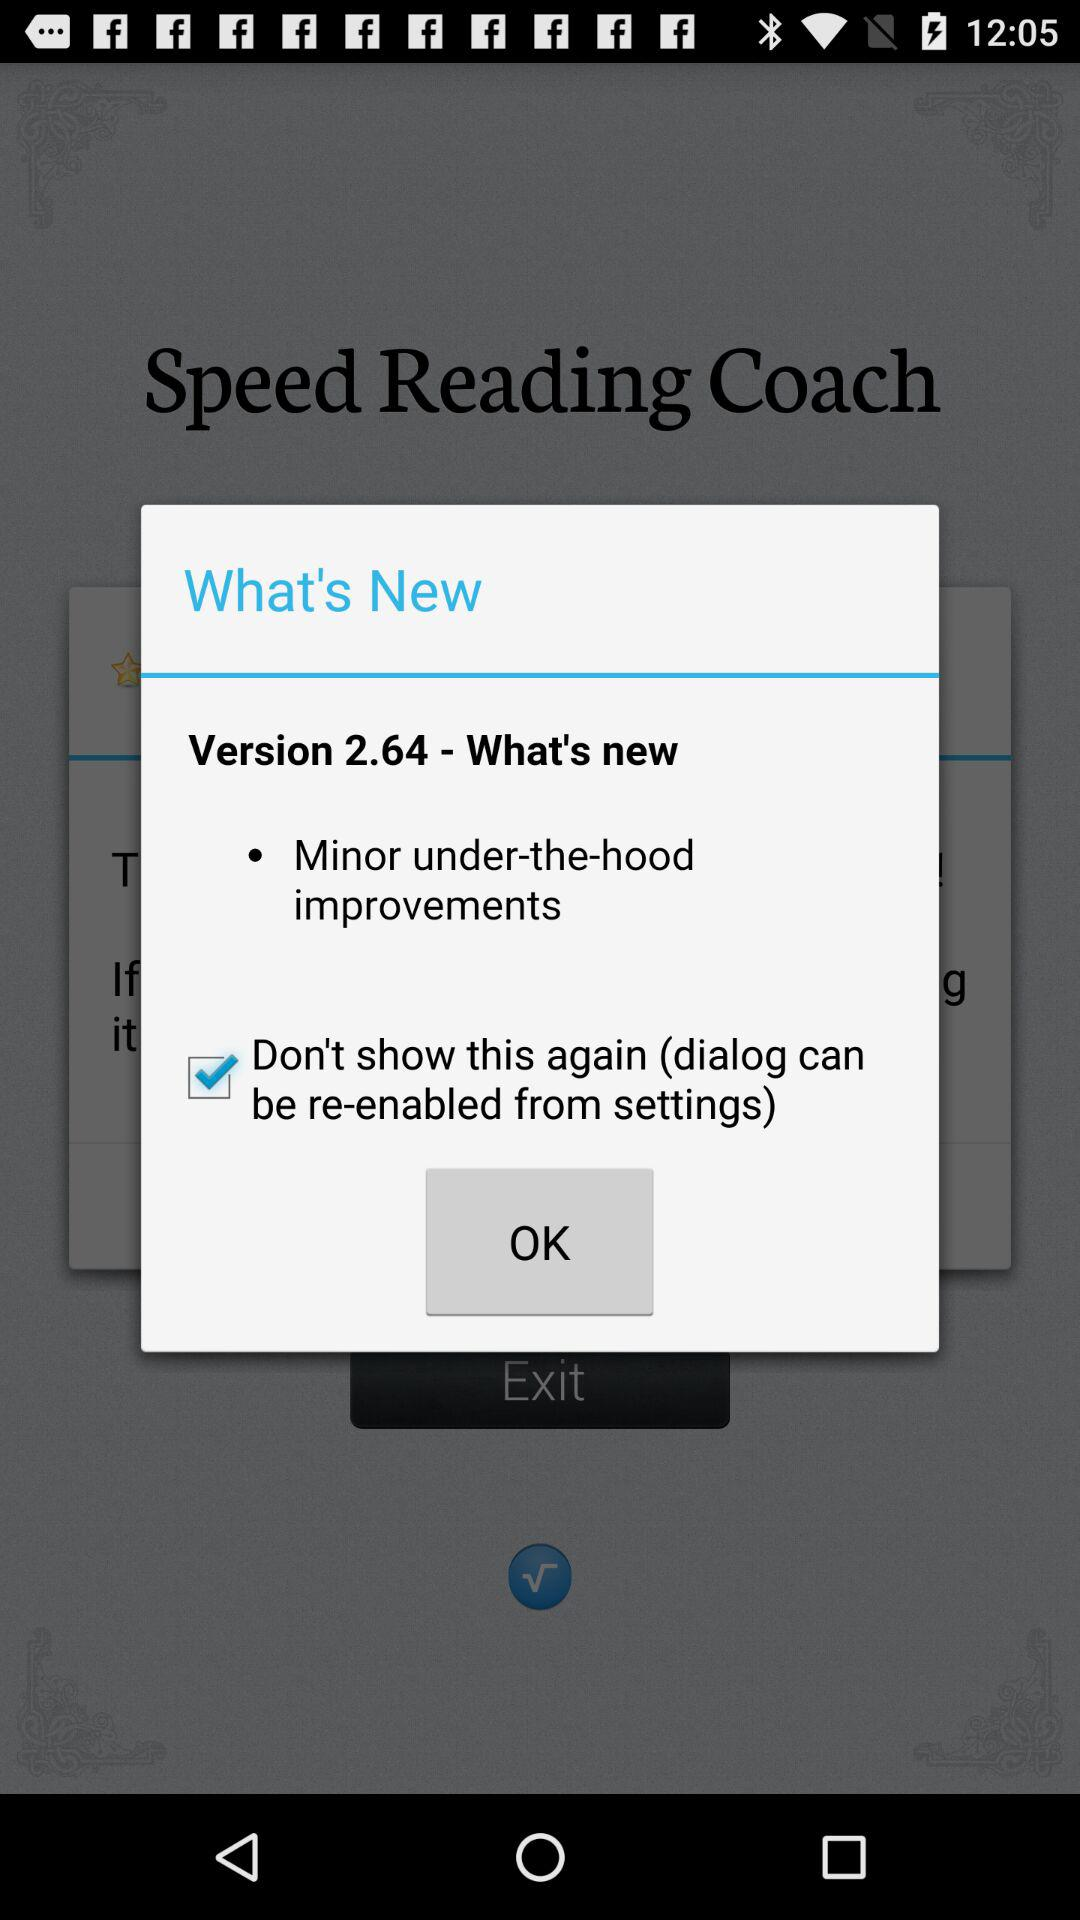Which option has been checked? The option that has been checked is "Don't show this again (dialog can be re-enabled from settings)". 